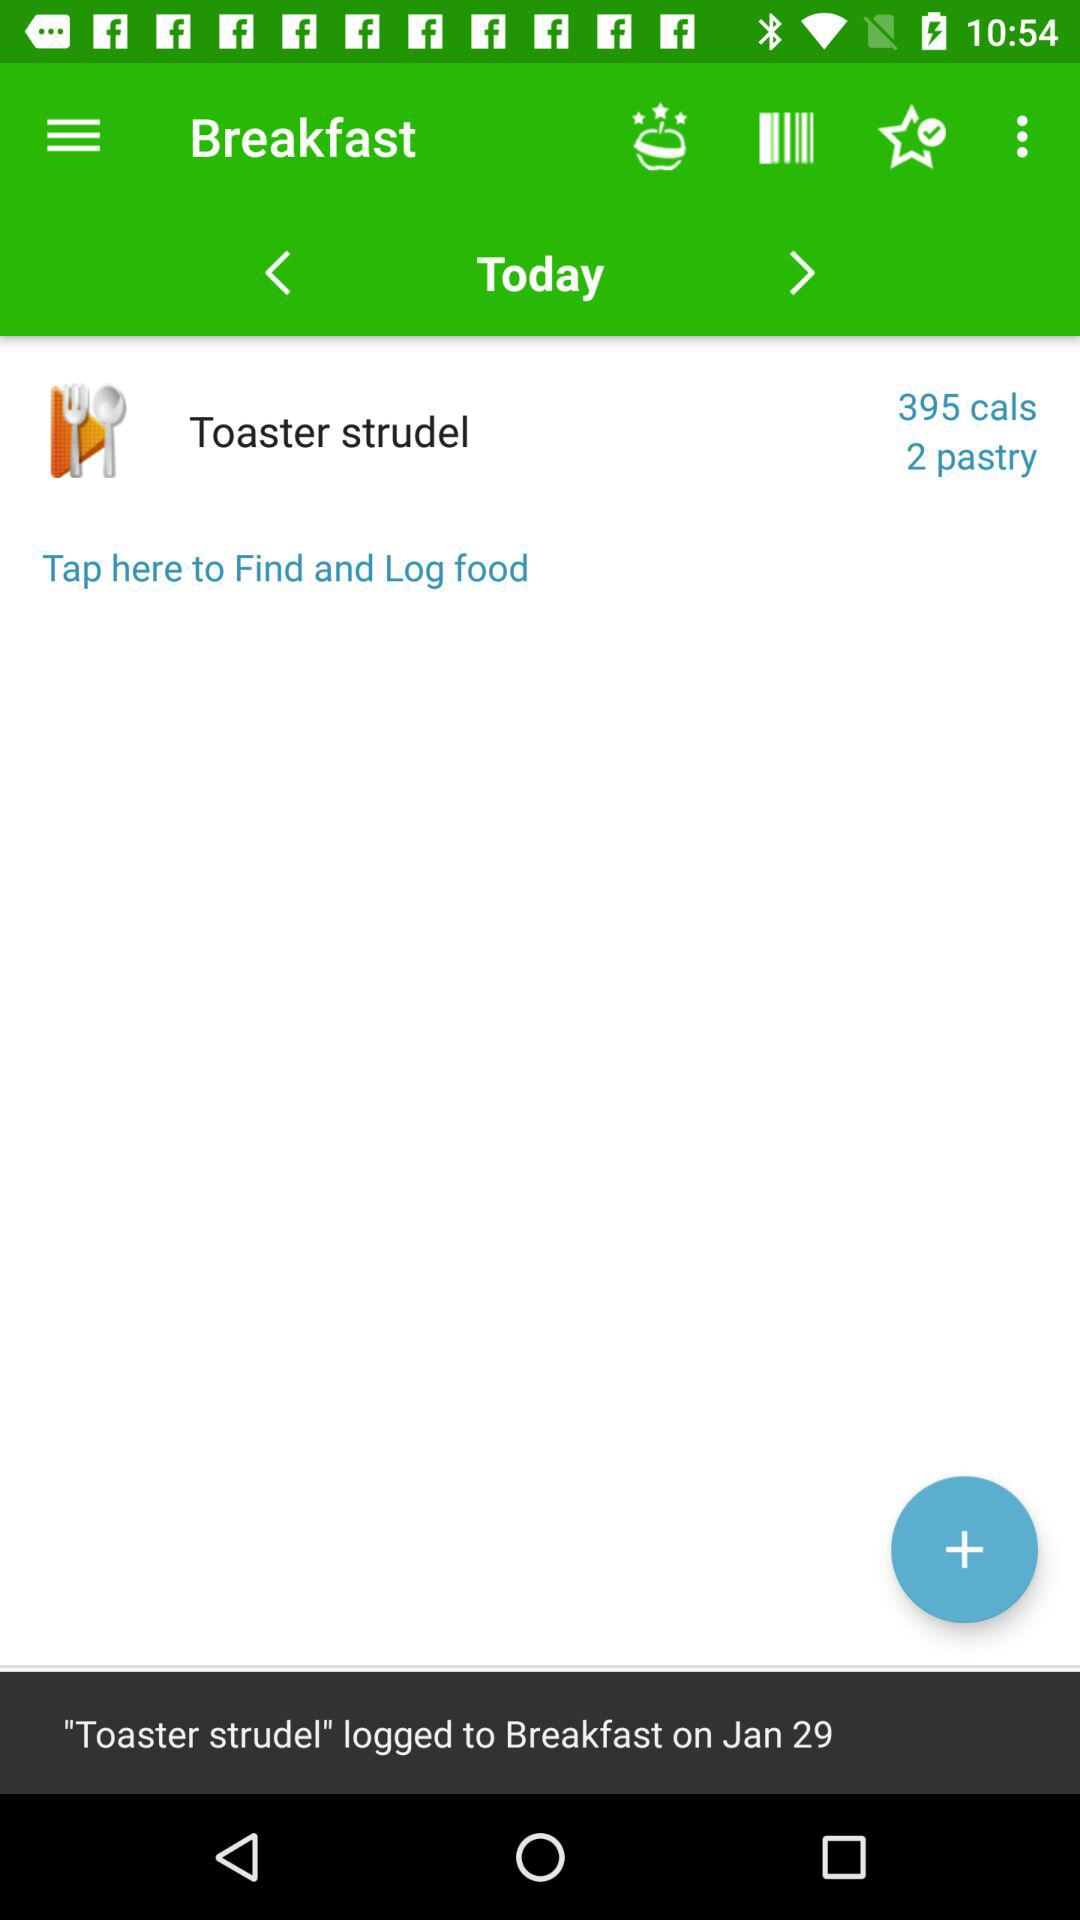Toaster strudel is logged on which date for the breakfast? Toaster Strudel is logged for breakfast on January 29. 